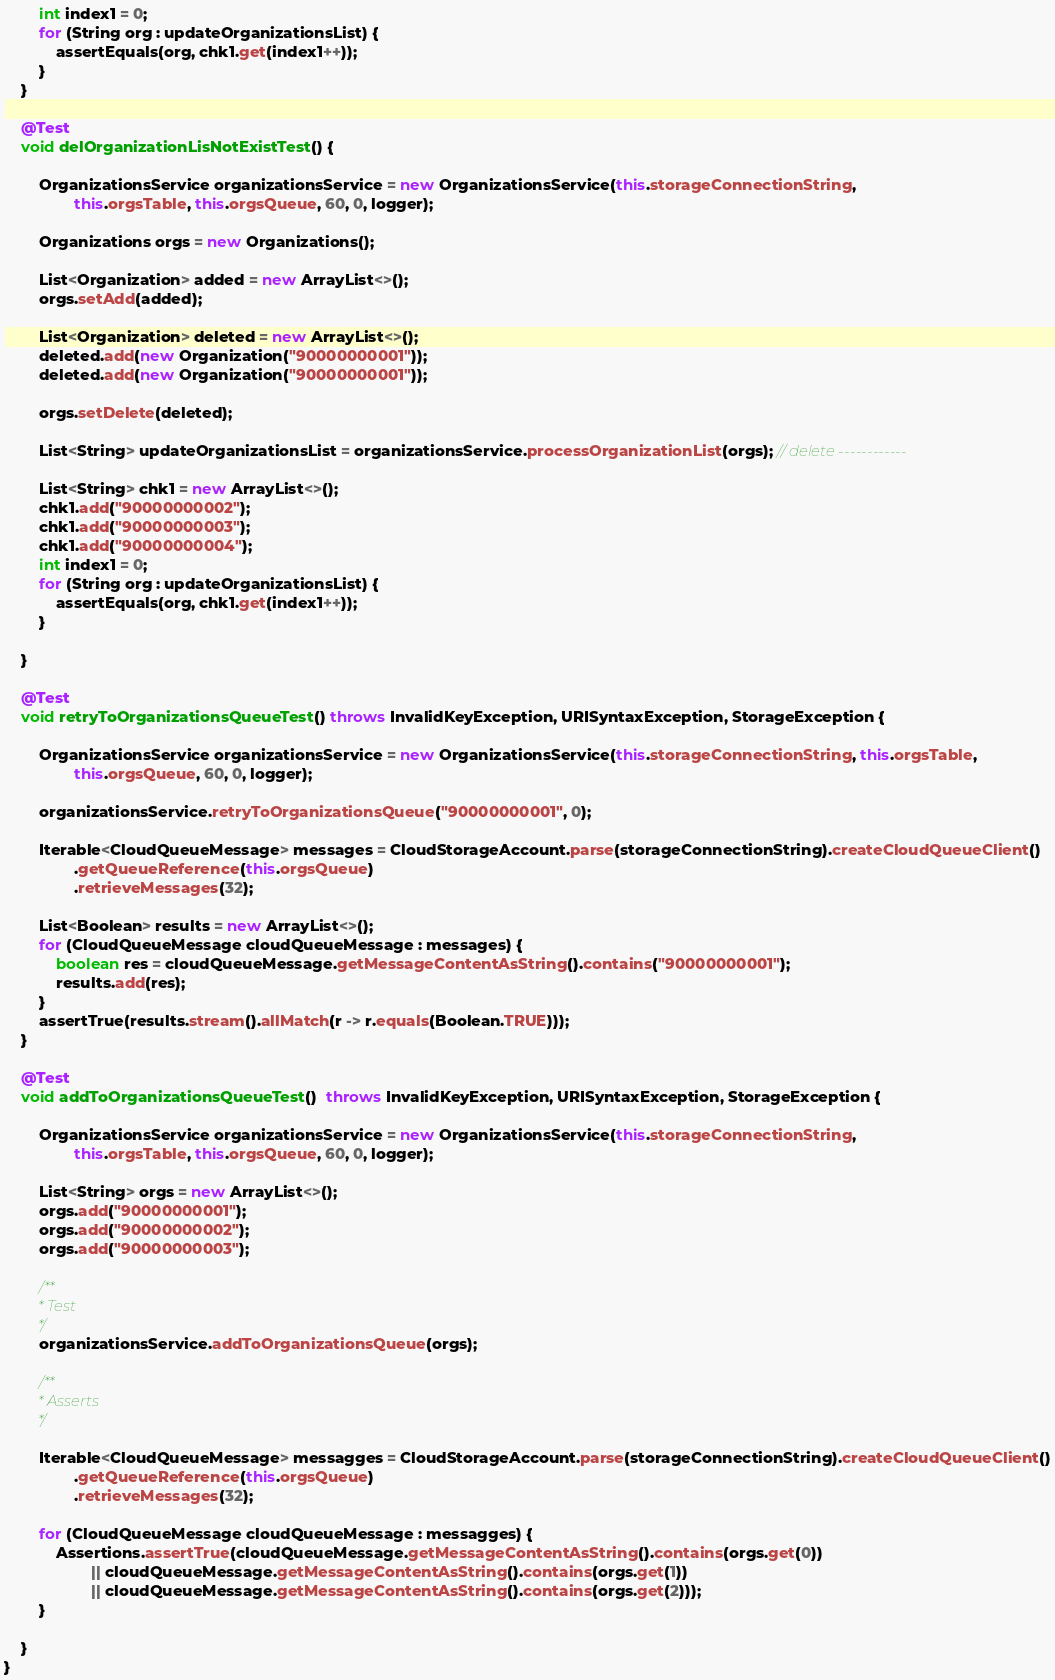Convert code to text. <code><loc_0><loc_0><loc_500><loc_500><_Java_>        int index1 = 0;
        for (String org : updateOrganizationsList) {
            assertEquals(org, chk1.get(index1++));
        }
    }

    @Test
    void delOrganizationLisNotExistTest() {

        OrganizationsService organizationsService = new OrganizationsService(this.storageConnectionString,
                this.orgsTable, this.orgsQueue, 60, 0, logger);

        Organizations orgs = new Organizations();

        List<Organization> added = new ArrayList<>();
        orgs.setAdd(added);

        List<Organization> deleted = new ArrayList<>();
        deleted.add(new Organization("90000000001"));
        deleted.add(new Organization("90000000001"));

        orgs.setDelete(deleted);

        List<String> updateOrganizationsList = organizationsService.processOrganizationList(orgs); // delete ------------

        List<String> chk1 = new ArrayList<>();
        chk1.add("90000000002");
        chk1.add("90000000003");
        chk1.add("90000000004");
        int index1 = 0;
        for (String org : updateOrganizationsList) {
            assertEquals(org, chk1.get(index1++));
        }

    }

    @Test
    void retryToOrganizationsQueueTest() throws InvalidKeyException, URISyntaxException, StorageException {

        OrganizationsService organizationsService = new OrganizationsService(this.storageConnectionString, this.orgsTable,
                this.orgsQueue, 60, 0, logger);

        organizationsService.retryToOrganizationsQueue("90000000001", 0);

        Iterable<CloudQueueMessage> messages = CloudStorageAccount.parse(storageConnectionString).createCloudQueueClient()
                .getQueueReference(this.orgsQueue)
                .retrieveMessages(32);

        List<Boolean> results = new ArrayList<>();
        for (CloudQueueMessage cloudQueueMessage : messages) {
            boolean res = cloudQueueMessage.getMessageContentAsString().contains("90000000001");
            results.add(res);
        }
        assertTrue(results.stream().allMatch(r -> r.equals(Boolean.TRUE)));
    }

    @Test
    void addToOrganizationsQueueTest()  throws InvalidKeyException, URISyntaxException, StorageException {

        OrganizationsService organizationsService = new OrganizationsService(this.storageConnectionString,
                this.orgsTable, this.orgsQueue, 60, 0, logger);

        List<String> orgs = new ArrayList<>();
        orgs.add("90000000001");
        orgs.add("90000000002");
        orgs.add("90000000003");

        /**
         * Test
         */
        organizationsService.addToOrganizationsQueue(orgs);

        /**
         * Asserts
         */

        Iterable<CloudQueueMessage> messagges = CloudStorageAccount.parse(storageConnectionString).createCloudQueueClient()
                .getQueueReference(this.orgsQueue)
                .retrieveMessages(32);

        for (CloudQueueMessage cloudQueueMessage : messagges) {
            Assertions.assertTrue(cloudQueueMessage.getMessageContentAsString().contains(orgs.get(0))
                    || cloudQueueMessage.getMessageContentAsString().contains(orgs.get(1))
                    || cloudQueueMessage.getMessageContentAsString().contains(orgs.get(2)));
        }

    }
}
</code> 